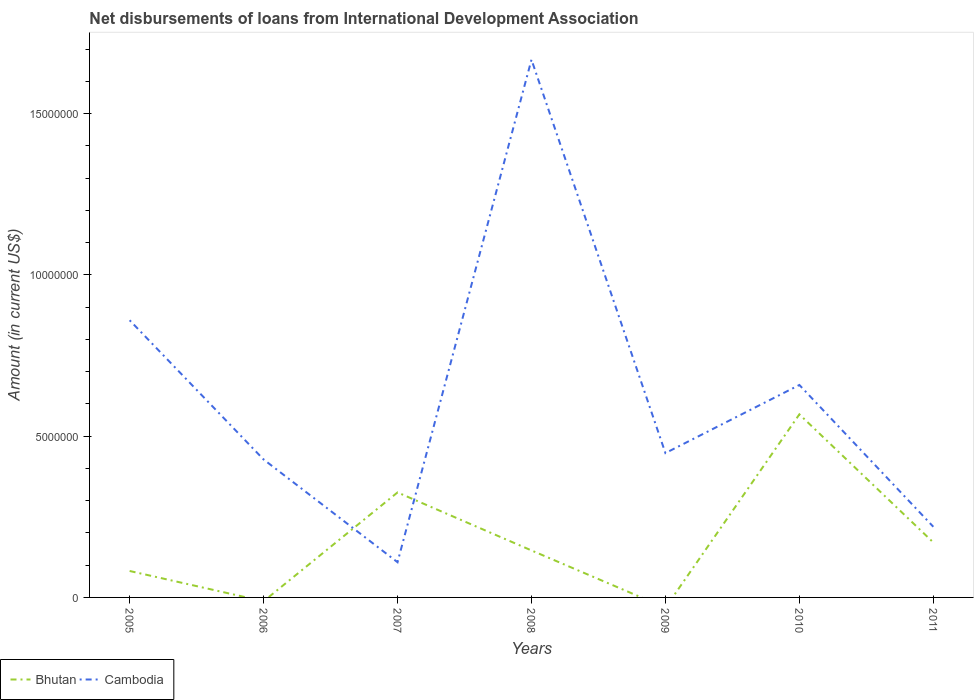How many different coloured lines are there?
Offer a terse response. 2. Does the line corresponding to Bhutan intersect with the line corresponding to Cambodia?
Offer a terse response. Yes. Is the number of lines equal to the number of legend labels?
Offer a terse response. No. What is the total amount of loans disbursed in Bhutan in the graph?
Provide a short and direct response. -2.44e+06. What is the difference between the highest and the second highest amount of loans disbursed in Cambodia?
Keep it short and to the point. 1.56e+07. What is the difference between the highest and the lowest amount of loans disbursed in Cambodia?
Your answer should be compact. 3. How many lines are there?
Your answer should be very brief. 2. How many years are there in the graph?
Give a very brief answer. 7. How many legend labels are there?
Your answer should be compact. 2. How are the legend labels stacked?
Ensure brevity in your answer.  Horizontal. What is the title of the graph?
Make the answer very short. Net disbursements of loans from International Development Association. Does "Djibouti" appear as one of the legend labels in the graph?
Your answer should be compact. No. What is the label or title of the X-axis?
Your response must be concise. Years. What is the Amount (in current US$) of Bhutan in 2005?
Give a very brief answer. 8.20e+05. What is the Amount (in current US$) of Cambodia in 2005?
Provide a short and direct response. 8.60e+06. What is the Amount (in current US$) in Cambodia in 2006?
Keep it short and to the point. 4.28e+06. What is the Amount (in current US$) in Bhutan in 2007?
Give a very brief answer. 3.26e+06. What is the Amount (in current US$) in Cambodia in 2007?
Keep it short and to the point. 1.09e+06. What is the Amount (in current US$) in Bhutan in 2008?
Keep it short and to the point. 1.46e+06. What is the Amount (in current US$) of Cambodia in 2008?
Ensure brevity in your answer.  1.67e+07. What is the Amount (in current US$) in Cambodia in 2009?
Give a very brief answer. 4.48e+06. What is the Amount (in current US$) in Bhutan in 2010?
Your answer should be very brief. 5.68e+06. What is the Amount (in current US$) of Cambodia in 2010?
Offer a very short reply. 6.59e+06. What is the Amount (in current US$) of Bhutan in 2011?
Make the answer very short. 1.70e+06. What is the Amount (in current US$) in Cambodia in 2011?
Your response must be concise. 2.19e+06. Across all years, what is the maximum Amount (in current US$) in Bhutan?
Your response must be concise. 5.68e+06. Across all years, what is the maximum Amount (in current US$) of Cambodia?
Your response must be concise. 1.67e+07. Across all years, what is the minimum Amount (in current US$) in Cambodia?
Keep it short and to the point. 1.09e+06. What is the total Amount (in current US$) of Bhutan in the graph?
Keep it short and to the point. 1.29e+07. What is the total Amount (in current US$) of Cambodia in the graph?
Make the answer very short. 4.39e+07. What is the difference between the Amount (in current US$) of Cambodia in 2005 and that in 2006?
Provide a short and direct response. 4.32e+06. What is the difference between the Amount (in current US$) of Bhutan in 2005 and that in 2007?
Provide a short and direct response. -2.44e+06. What is the difference between the Amount (in current US$) of Cambodia in 2005 and that in 2007?
Provide a succinct answer. 7.50e+06. What is the difference between the Amount (in current US$) in Bhutan in 2005 and that in 2008?
Your response must be concise. -6.37e+05. What is the difference between the Amount (in current US$) of Cambodia in 2005 and that in 2008?
Offer a very short reply. -8.08e+06. What is the difference between the Amount (in current US$) in Cambodia in 2005 and that in 2009?
Provide a short and direct response. 4.12e+06. What is the difference between the Amount (in current US$) of Bhutan in 2005 and that in 2010?
Make the answer very short. -4.86e+06. What is the difference between the Amount (in current US$) in Cambodia in 2005 and that in 2010?
Offer a very short reply. 2.01e+06. What is the difference between the Amount (in current US$) in Bhutan in 2005 and that in 2011?
Keep it short and to the point. -8.85e+05. What is the difference between the Amount (in current US$) in Cambodia in 2005 and that in 2011?
Your answer should be very brief. 6.40e+06. What is the difference between the Amount (in current US$) of Cambodia in 2006 and that in 2007?
Make the answer very short. 3.19e+06. What is the difference between the Amount (in current US$) of Cambodia in 2006 and that in 2008?
Ensure brevity in your answer.  -1.24e+07. What is the difference between the Amount (in current US$) in Cambodia in 2006 and that in 2009?
Give a very brief answer. -1.98e+05. What is the difference between the Amount (in current US$) in Cambodia in 2006 and that in 2010?
Your answer should be very brief. -2.31e+06. What is the difference between the Amount (in current US$) in Cambodia in 2006 and that in 2011?
Give a very brief answer. 2.09e+06. What is the difference between the Amount (in current US$) of Bhutan in 2007 and that in 2008?
Your response must be concise. 1.80e+06. What is the difference between the Amount (in current US$) of Cambodia in 2007 and that in 2008?
Keep it short and to the point. -1.56e+07. What is the difference between the Amount (in current US$) of Cambodia in 2007 and that in 2009?
Provide a short and direct response. -3.38e+06. What is the difference between the Amount (in current US$) in Bhutan in 2007 and that in 2010?
Your answer should be compact. -2.42e+06. What is the difference between the Amount (in current US$) of Cambodia in 2007 and that in 2010?
Offer a very short reply. -5.50e+06. What is the difference between the Amount (in current US$) in Bhutan in 2007 and that in 2011?
Make the answer very short. 1.55e+06. What is the difference between the Amount (in current US$) of Cambodia in 2007 and that in 2011?
Offer a terse response. -1.10e+06. What is the difference between the Amount (in current US$) in Cambodia in 2008 and that in 2009?
Offer a terse response. 1.22e+07. What is the difference between the Amount (in current US$) of Bhutan in 2008 and that in 2010?
Give a very brief answer. -4.22e+06. What is the difference between the Amount (in current US$) in Cambodia in 2008 and that in 2010?
Your answer should be compact. 1.01e+07. What is the difference between the Amount (in current US$) of Bhutan in 2008 and that in 2011?
Provide a short and direct response. -2.48e+05. What is the difference between the Amount (in current US$) in Cambodia in 2008 and that in 2011?
Your answer should be very brief. 1.45e+07. What is the difference between the Amount (in current US$) of Cambodia in 2009 and that in 2010?
Give a very brief answer. -2.11e+06. What is the difference between the Amount (in current US$) in Cambodia in 2009 and that in 2011?
Your answer should be very brief. 2.28e+06. What is the difference between the Amount (in current US$) in Bhutan in 2010 and that in 2011?
Give a very brief answer. 3.97e+06. What is the difference between the Amount (in current US$) in Cambodia in 2010 and that in 2011?
Give a very brief answer. 4.40e+06. What is the difference between the Amount (in current US$) of Bhutan in 2005 and the Amount (in current US$) of Cambodia in 2006?
Your response must be concise. -3.46e+06. What is the difference between the Amount (in current US$) in Bhutan in 2005 and the Amount (in current US$) in Cambodia in 2007?
Your answer should be very brief. -2.72e+05. What is the difference between the Amount (in current US$) in Bhutan in 2005 and the Amount (in current US$) in Cambodia in 2008?
Offer a terse response. -1.59e+07. What is the difference between the Amount (in current US$) in Bhutan in 2005 and the Amount (in current US$) in Cambodia in 2009?
Provide a short and direct response. -3.66e+06. What is the difference between the Amount (in current US$) in Bhutan in 2005 and the Amount (in current US$) in Cambodia in 2010?
Your answer should be very brief. -5.77e+06. What is the difference between the Amount (in current US$) of Bhutan in 2005 and the Amount (in current US$) of Cambodia in 2011?
Ensure brevity in your answer.  -1.37e+06. What is the difference between the Amount (in current US$) of Bhutan in 2007 and the Amount (in current US$) of Cambodia in 2008?
Offer a terse response. -1.34e+07. What is the difference between the Amount (in current US$) in Bhutan in 2007 and the Amount (in current US$) in Cambodia in 2009?
Provide a succinct answer. -1.22e+06. What is the difference between the Amount (in current US$) of Bhutan in 2007 and the Amount (in current US$) of Cambodia in 2010?
Provide a succinct answer. -3.33e+06. What is the difference between the Amount (in current US$) in Bhutan in 2007 and the Amount (in current US$) in Cambodia in 2011?
Provide a short and direct response. 1.06e+06. What is the difference between the Amount (in current US$) of Bhutan in 2008 and the Amount (in current US$) of Cambodia in 2009?
Keep it short and to the point. -3.02e+06. What is the difference between the Amount (in current US$) of Bhutan in 2008 and the Amount (in current US$) of Cambodia in 2010?
Provide a short and direct response. -5.13e+06. What is the difference between the Amount (in current US$) of Bhutan in 2008 and the Amount (in current US$) of Cambodia in 2011?
Ensure brevity in your answer.  -7.34e+05. What is the difference between the Amount (in current US$) in Bhutan in 2010 and the Amount (in current US$) in Cambodia in 2011?
Provide a short and direct response. 3.49e+06. What is the average Amount (in current US$) of Bhutan per year?
Your answer should be compact. 1.84e+06. What is the average Amount (in current US$) in Cambodia per year?
Your answer should be very brief. 6.27e+06. In the year 2005, what is the difference between the Amount (in current US$) of Bhutan and Amount (in current US$) of Cambodia?
Make the answer very short. -7.78e+06. In the year 2007, what is the difference between the Amount (in current US$) in Bhutan and Amount (in current US$) in Cambodia?
Your response must be concise. 2.16e+06. In the year 2008, what is the difference between the Amount (in current US$) of Bhutan and Amount (in current US$) of Cambodia?
Offer a very short reply. -1.52e+07. In the year 2010, what is the difference between the Amount (in current US$) in Bhutan and Amount (in current US$) in Cambodia?
Offer a terse response. -9.11e+05. In the year 2011, what is the difference between the Amount (in current US$) in Bhutan and Amount (in current US$) in Cambodia?
Make the answer very short. -4.86e+05. What is the ratio of the Amount (in current US$) of Cambodia in 2005 to that in 2006?
Make the answer very short. 2.01. What is the ratio of the Amount (in current US$) of Bhutan in 2005 to that in 2007?
Ensure brevity in your answer.  0.25. What is the ratio of the Amount (in current US$) in Cambodia in 2005 to that in 2007?
Provide a short and direct response. 7.87. What is the ratio of the Amount (in current US$) in Bhutan in 2005 to that in 2008?
Your answer should be compact. 0.56. What is the ratio of the Amount (in current US$) of Cambodia in 2005 to that in 2008?
Keep it short and to the point. 0.52. What is the ratio of the Amount (in current US$) of Cambodia in 2005 to that in 2009?
Make the answer very short. 1.92. What is the ratio of the Amount (in current US$) in Bhutan in 2005 to that in 2010?
Provide a short and direct response. 0.14. What is the ratio of the Amount (in current US$) in Cambodia in 2005 to that in 2010?
Offer a terse response. 1.3. What is the ratio of the Amount (in current US$) of Bhutan in 2005 to that in 2011?
Offer a terse response. 0.48. What is the ratio of the Amount (in current US$) in Cambodia in 2005 to that in 2011?
Provide a succinct answer. 3.92. What is the ratio of the Amount (in current US$) of Cambodia in 2006 to that in 2007?
Give a very brief answer. 3.92. What is the ratio of the Amount (in current US$) of Cambodia in 2006 to that in 2008?
Provide a short and direct response. 0.26. What is the ratio of the Amount (in current US$) of Cambodia in 2006 to that in 2009?
Ensure brevity in your answer.  0.96. What is the ratio of the Amount (in current US$) of Cambodia in 2006 to that in 2010?
Your answer should be very brief. 0.65. What is the ratio of the Amount (in current US$) in Cambodia in 2006 to that in 2011?
Provide a succinct answer. 1.95. What is the ratio of the Amount (in current US$) of Bhutan in 2007 to that in 2008?
Your response must be concise. 2.23. What is the ratio of the Amount (in current US$) of Cambodia in 2007 to that in 2008?
Your answer should be compact. 0.07. What is the ratio of the Amount (in current US$) in Cambodia in 2007 to that in 2009?
Offer a very short reply. 0.24. What is the ratio of the Amount (in current US$) in Bhutan in 2007 to that in 2010?
Ensure brevity in your answer.  0.57. What is the ratio of the Amount (in current US$) of Cambodia in 2007 to that in 2010?
Offer a very short reply. 0.17. What is the ratio of the Amount (in current US$) in Bhutan in 2007 to that in 2011?
Offer a terse response. 1.91. What is the ratio of the Amount (in current US$) of Cambodia in 2007 to that in 2011?
Your answer should be very brief. 0.5. What is the ratio of the Amount (in current US$) of Cambodia in 2008 to that in 2009?
Ensure brevity in your answer.  3.73. What is the ratio of the Amount (in current US$) of Bhutan in 2008 to that in 2010?
Give a very brief answer. 0.26. What is the ratio of the Amount (in current US$) in Cambodia in 2008 to that in 2010?
Offer a terse response. 2.53. What is the ratio of the Amount (in current US$) in Bhutan in 2008 to that in 2011?
Provide a succinct answer. 0.85. What is the ratio of the Amount (in current US$) of Cambodia in 2008 to that in 2011?
Your response must be concise. 7.61. What is the ratio of the Amount (in current US$) of Cambodia in 2009 to that in 2010?
Ensure brevity in your answer.  0.68. What is the ratio of the Amount (in current US$) of Cambodia in 2009 to that in 2011?
Provide a succinct answer. 2.04. What is the ratio of the Amount (in current US$) in Bhutan in 2010 to that in 2011?
Keep it short and to the point. 3.33. What is the ratio of the Amount (in current US$) of Cambodia in 2010 to that in 2011?
Provide a short and direct response. 3.01. What is the difference between the highest and the second highest Amount (in current US$) of Bhutan?
Ensure brevity in your answer.  2.42e+06. What is the difference between the highest and the second highest Amount (in current US$) in Cambodia?
Offer a very short reply. 8.08e+06. What is the difference between the highest and the lowest Amount (in current US$) of Bhutan?
Your answer should be compact. 5.68e+06. What is the difference between the highest and the lowest Amount (in current US$) in Cambodia?
Provide a succinct answer. 1.56e+07. 